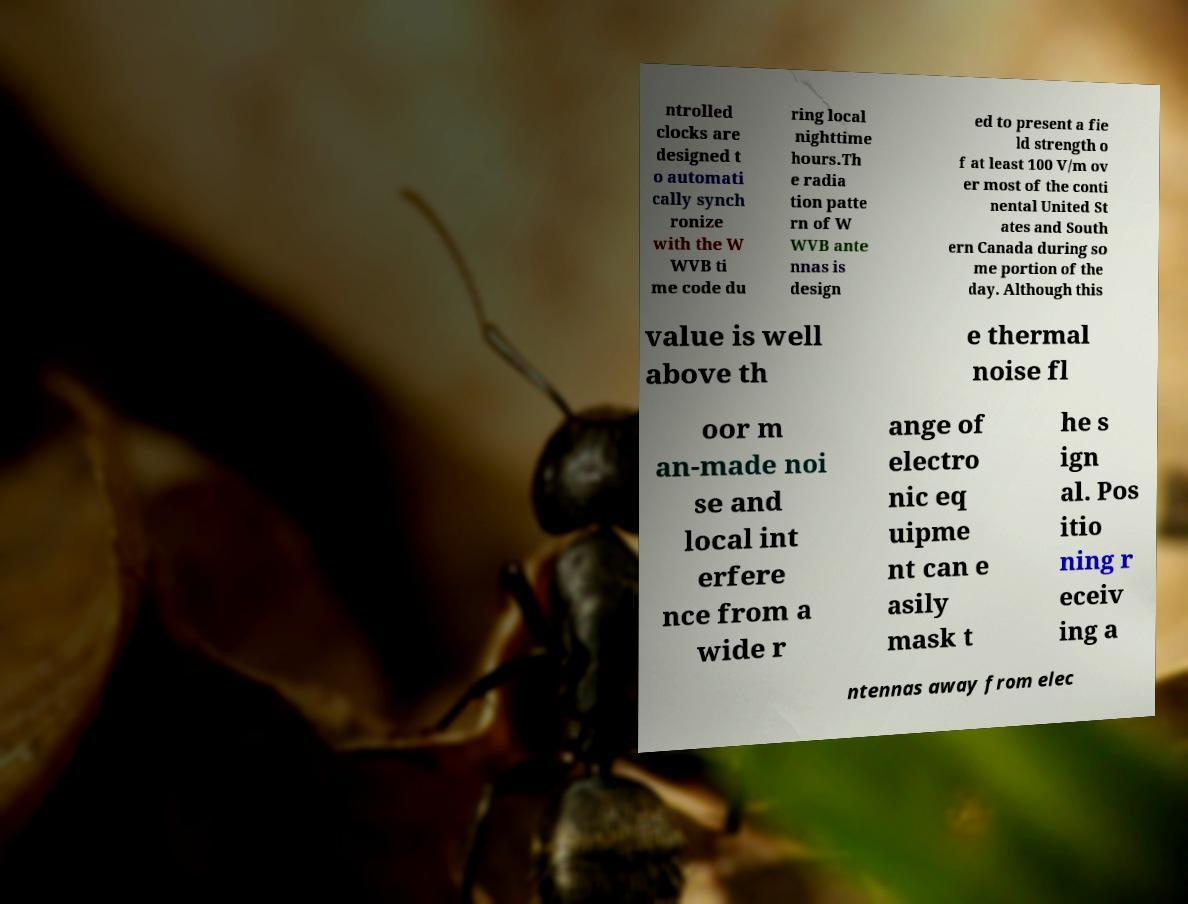Can you accurately transcribe the text from the provided image for me? ntrolled clocks are designed t o automati cally synch ronize with the W WVB ti me code du ring local nighttime hours.Th e radia tion patte rn of W WVB ante nnas is design ed to present a fie ld strength o f at least 100 V/m ov er most of the conti nental United St ates and South ern Canada during so me portion of the day. Although this value is well above th e thermal noise fl oor m an-made noi se and local int erfere nce from a wide r ange of electro nic eq uipme nt can e asily mask t he s ign al. Pos itio ning r eceiv ing a ntennas away from elec 